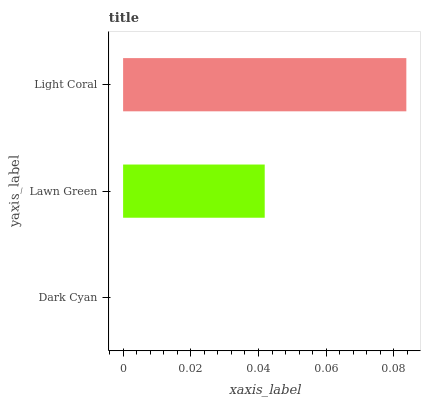Is Dark Cyan the minimum?
Answer yes or no. Yes. Is Light Coral the maximum?
Answer yes or no. Yes. Is Lawn Green the minimum?
Answer yes or no. No. Is Lawn Green the maximum?
Answer yes or no. No. Is Lawn Green greater than Dark Cyan?
Answer yes or no. Yes. Is Dark Cyan less than Lawn Green?
Answer yes or no. Yes. Is Dark Cyan greater than Lawn Green?
Answer yes or no. No. Is Lawn Green less than Dark Cyan?
Answer yes or no. No. Is Lawn Green the high median?
Answer yes or no. Yes. Is Lawn Green the low median?
Answer yes or no. Yes. Is Dark Cyan the high median?
Answer yes or no. No. Is Light Coral the low median?
Answer yes or no. No. 